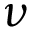Convert formula to latex. <formula><loc_0><loc_0><loc_500><loc_500>\nu</formula> 